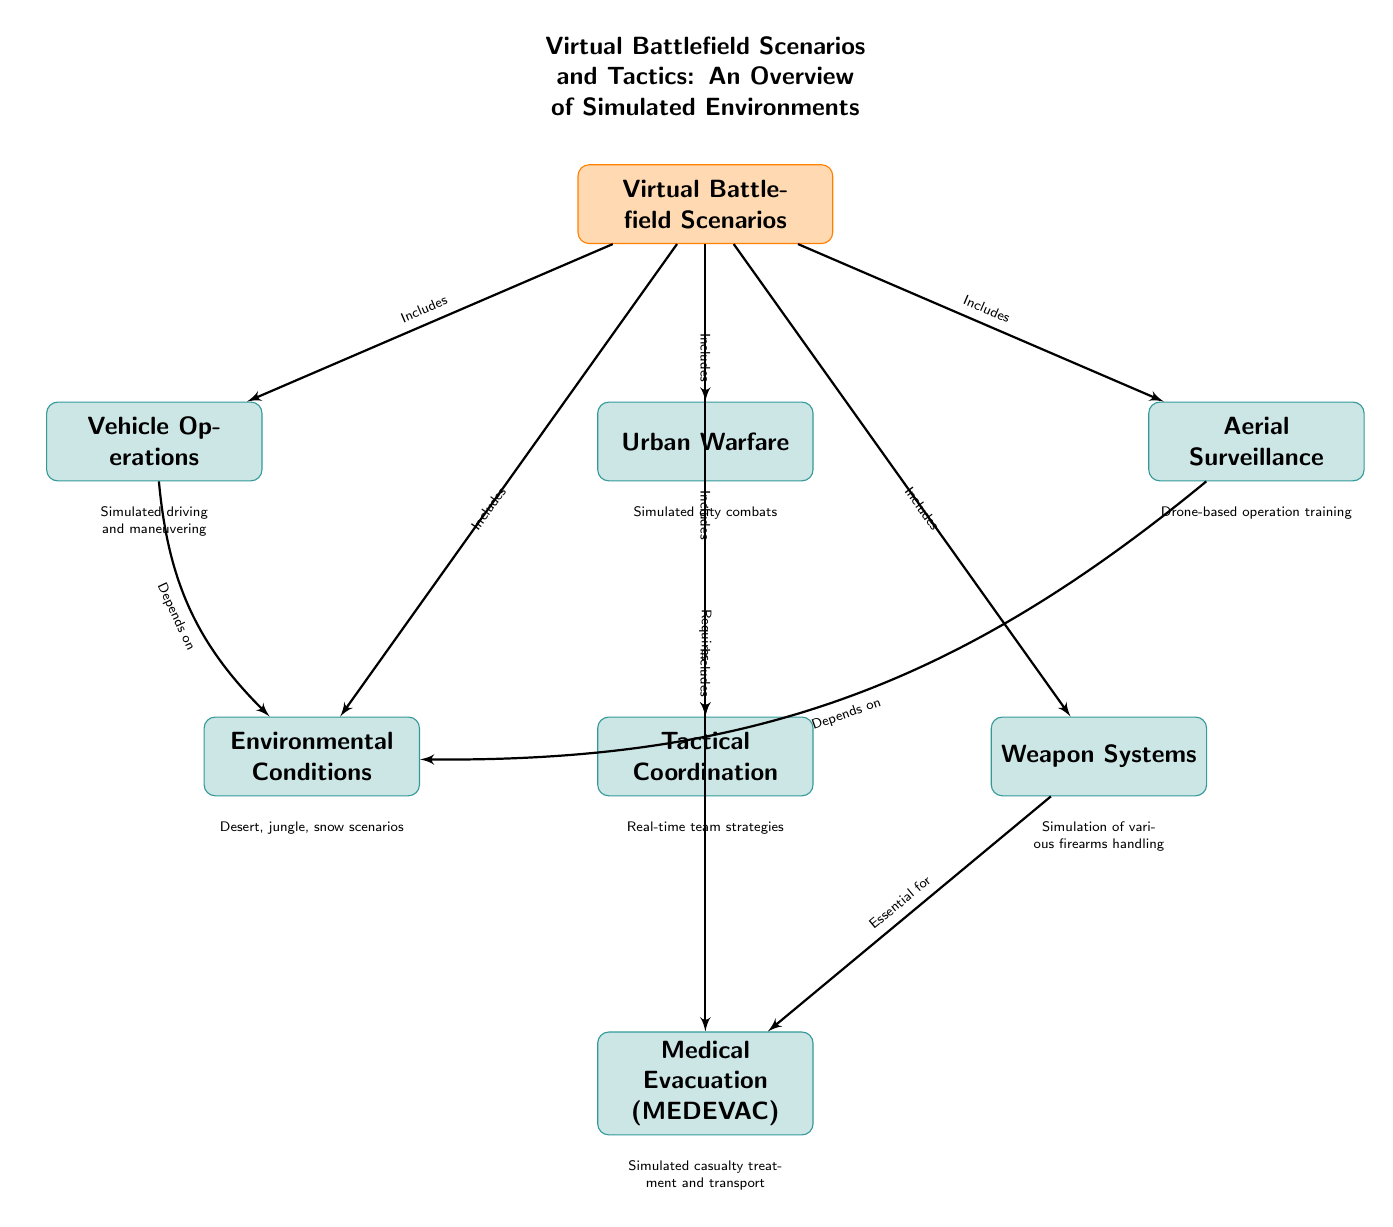What are the main categories included in the Virtual Battlefield Scenarios? The diagram lists Vehicle Operations, Urban Warfare, Aerial Surveillance, Tactical Coordination, Environmental Conditions, Weapon Systems, and Medical Evacuation as the main categories under Virtual Battlefield Scenarios.
Answer: Vehicle Operations, Urban Warfare, Aerial Surveillance, Tactical Coordination, Environmental Conditions, Weapon Systems, Medical Evacuation How many main categories are included in the diagram? The diagram shows a total of seven main categories included under the Virtual Battlefield Scenarios.
Answer: Seven Which category requires Tactical Coordination? According to the diagram, Urban Warfare requires Tactical Coordination as indicated by the arrow pointing from Urban Warfare to Tactical Coordination.
Answer: Urban Warfare What depends on Environmental Conditions? The diagram indicates that both Vehicle Operations and Aerial Surveillance depend on Environmental Conditions, as shown by the bent edges leading from both categories to Environmental Conditions.
Answer: Vehicle Operations, Aerial Surveillance What is the relationship between Weapon Systems and Medical Evacuation? The diagram states that Weapon Systems is essential for Medical Evacuation, as shown by the arrows indicating dependencies between these two categories.
Answer: Essential for What type of training is associated with Aerial Surveillance? The diagram mentions that Aerial Surveillance involves drone-based operation training, which is described below the Aerial Surveillance node.
Answer: Drone-based operation training Which category is at the top of the hierarchy? The diagram indicates that Virtual Battlefield Scenarios is the top category, as it is positioned at the top of the diagram and connects to all other categories.
Answer: Virtual Battlefield Scenarios What key environments are simulated under Environmental Conditions? The diagram lists desert, jungle, and snow scenarios as key environments under Environmental Conditions, which are described below the node.
Answer: Desert, jungle, snow scenarios Which category involves simulated casualty treatment and transport? Medical Evacuation (MEDEVAC) is the category associated with simulated casualty treatment and transport according to the description in the diagram.
Answer: Medical Evacuation (MEDEVAC) 